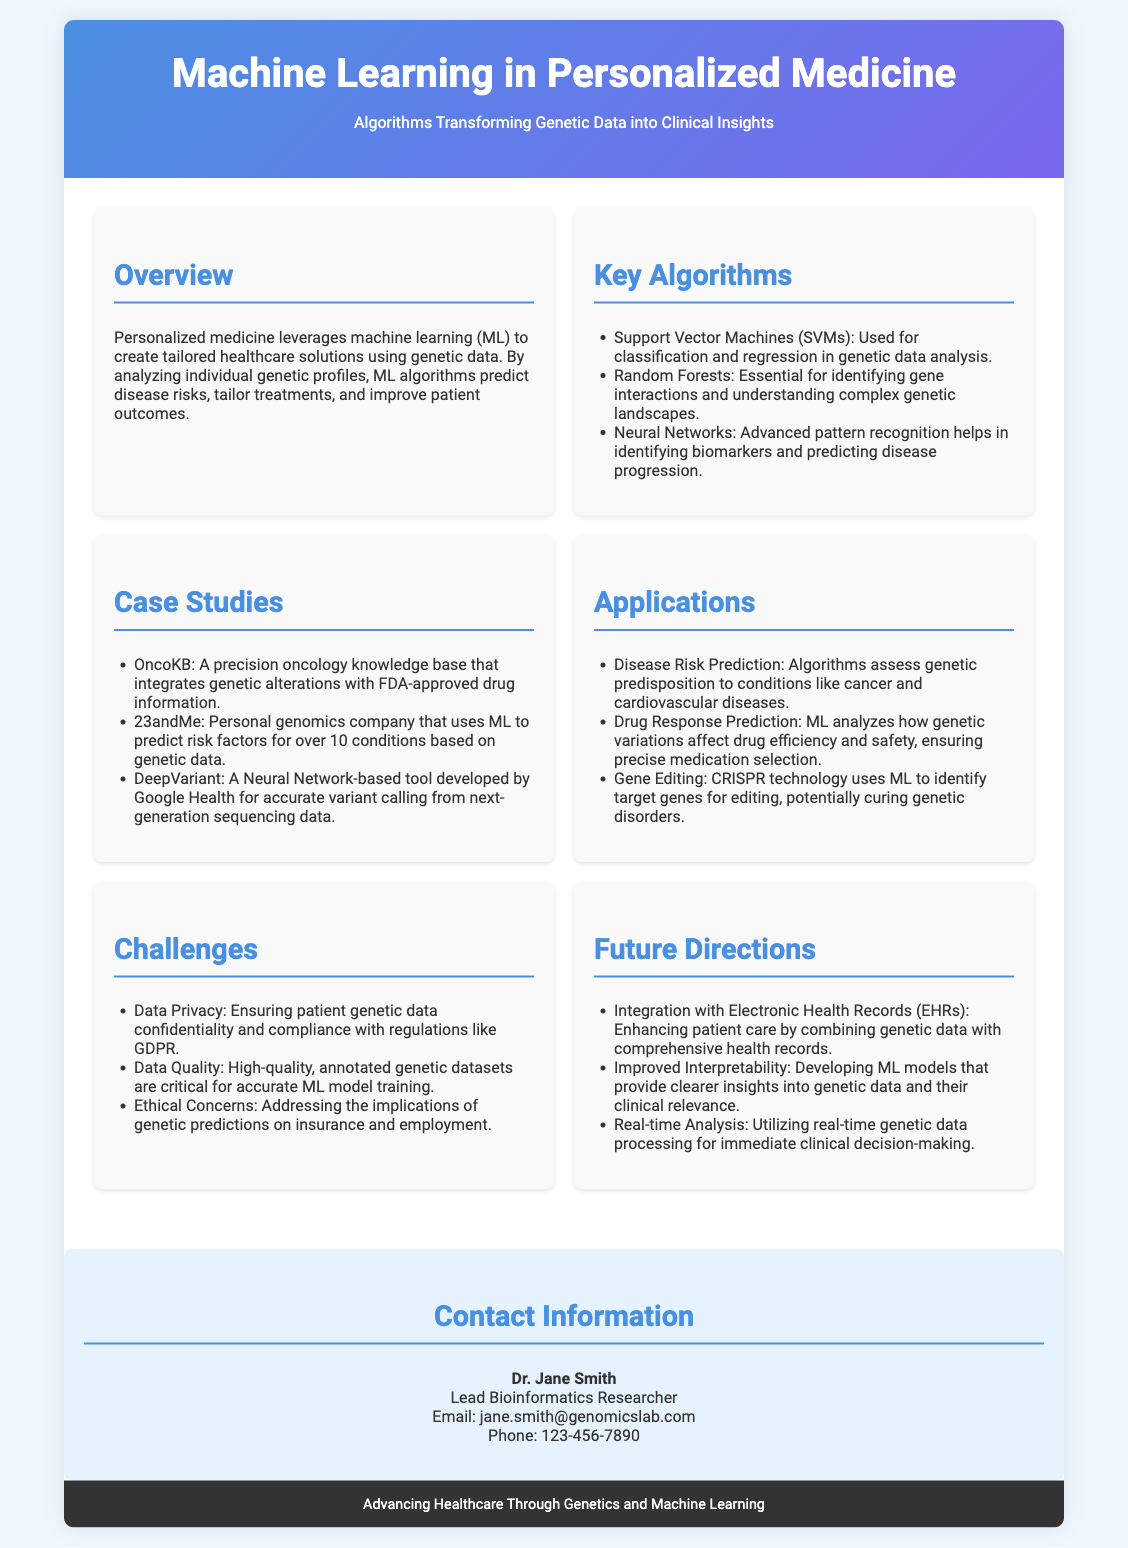What is the title of the flyer? The title is prominently featured at the top of the document, which states "Machine Learning in Personalized Medicine".
Answer: Machine Learning in Personalized Medicine Who is the lead researcher mentioned in the contact information? The document specifies the contact information section that lists Dr. Jane Smith as the lead bioinformatics researcher.
Answer: Dr. Jane Smith What is one application of machine learning mentioned in the document? The document lists various applications, and one of them is related to disease risk prediction.
Answer: Disease Risk Prediction What algorithm is used for identifying gene interactions? The document highlights Random Forests specifically for identifying gene interactions in genetic data analysis.
Answer: Random Forests What is a challenge related to data in personalized medicine? The document mentions data quality as a significant challenge that requires high-quality, annotated genetic datasets.
Answer: Data Quality What is a future direction for machine learning in personalized medicine? One future direction mentioned is the integration with electronic health records to enhance patient care.
Answer: Integration with Electronic Health Records How many case studies are provided in the document? The document lists three case studies under the section labeled "Case Studies".
Answer: Three What is the gradient color of the header? The header background uses a linear gradient from #4a90e2 to #7b68ee, as described in the style definitions.
Answer: #4a90e2 to #7b68ee 